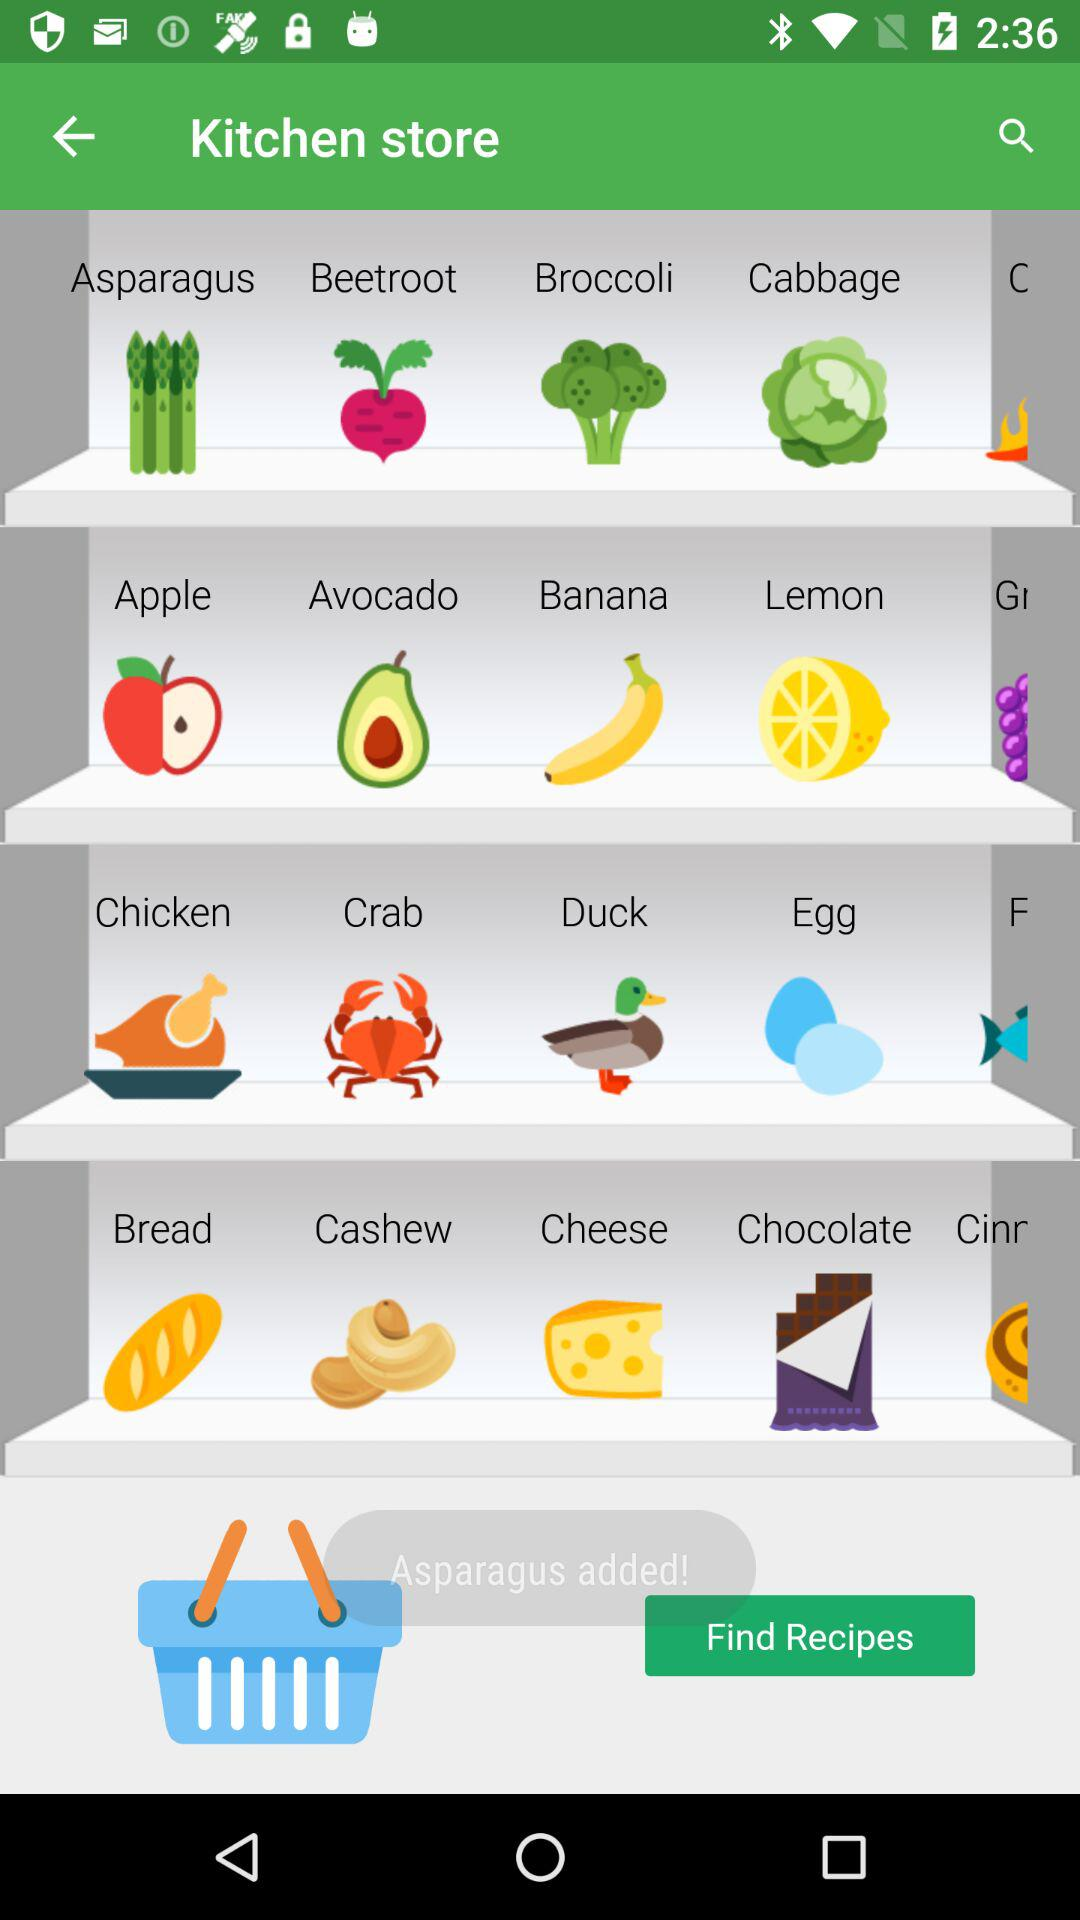Which item is added to the cart? The item that is added to the cart is asparagus. 